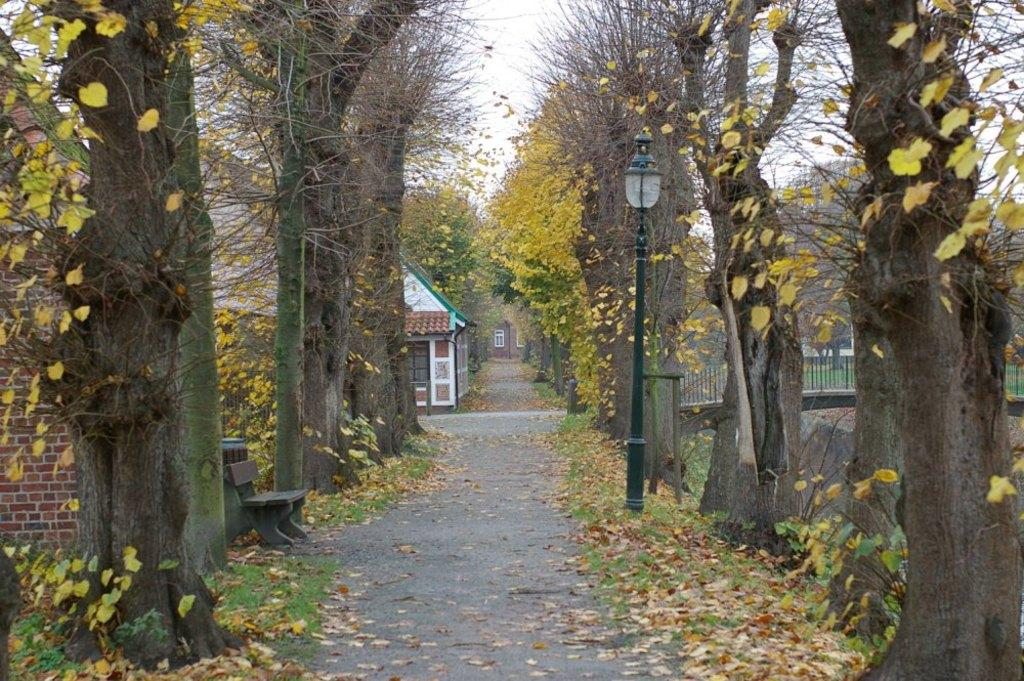What is the primary feature of the landscape in the image? There are many trees in the image. What can be seen running through the trees in the image? There is a road in the middle of the image. What type of structure is visible in the background? There is a house in the background of the image. What is located on the right side of the image? There is a fencing on the right side of the image. What might be causing the road to appear different in the image? There are leaves on the road. What type of tax is being discussed in the image? There is no discussion of tax in the image; it primarily features trees, a road, a house, fencing, and leaves on the road. 